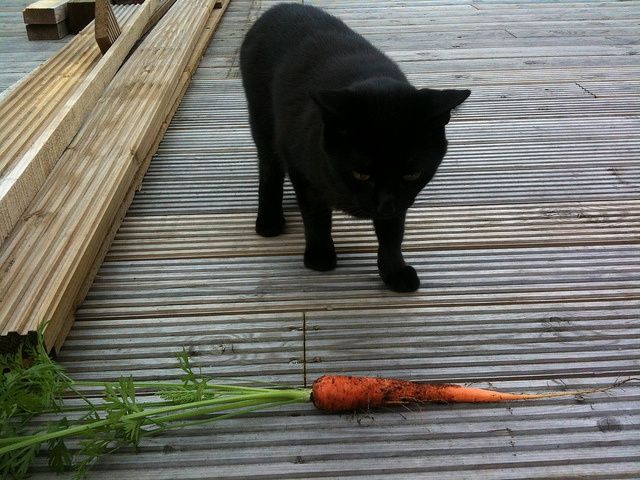Describe the objects in this image and their specific colors. I can see cat in darkgray, black, and gray tones and carrot in darkgray, black, darkgreen, and gray tones in this image. 